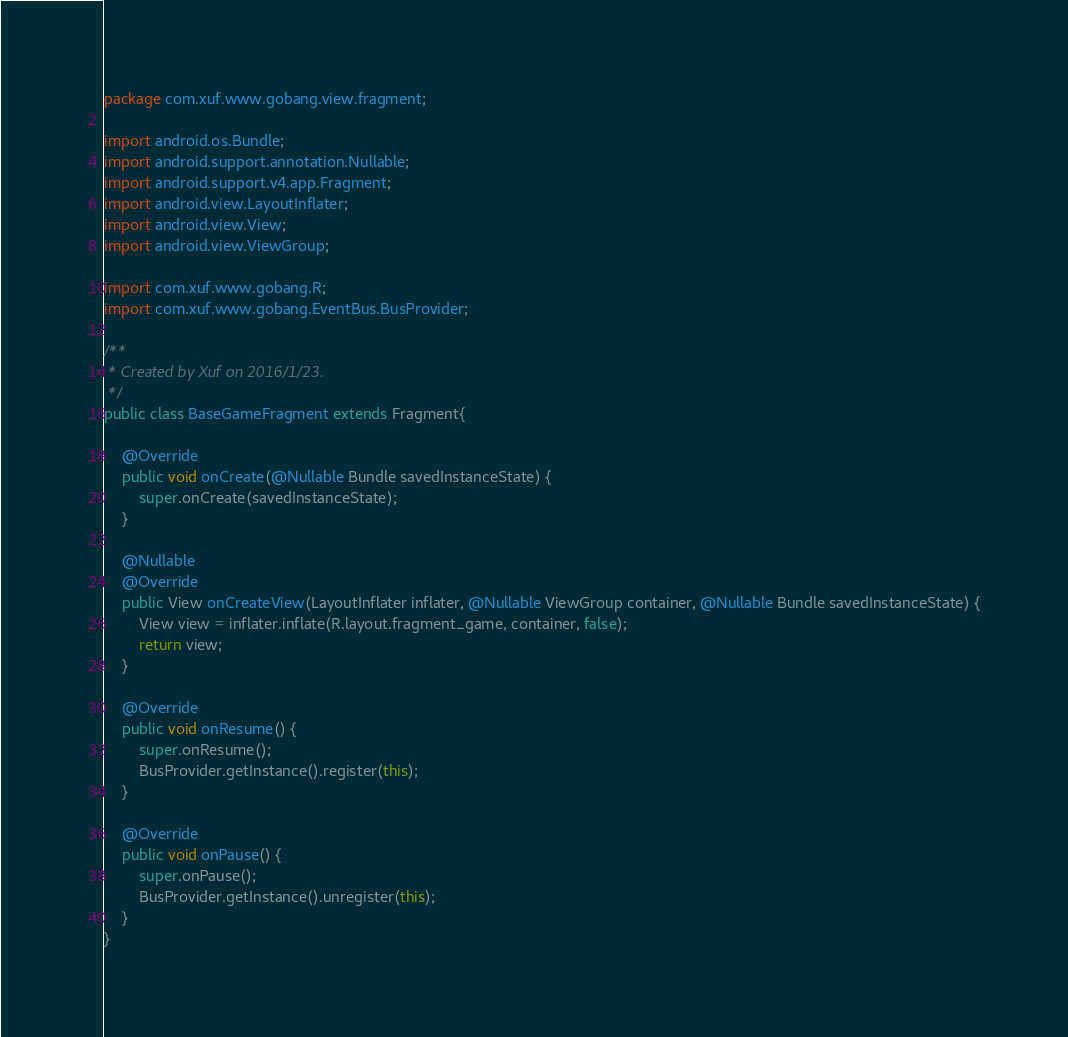<code> <loc_0><loc_0><loc_500><loc_500><_Java_>package com.xuf.www.gobang.view.fragment;

import android.os.Bundle;
import android.support.annotation.Nullable;
import android.support.v4.app.Fragment;
import android.view.LayoutInflater;
import android.view.View;
import android.view.ViewGroup;

import com.xuf.www.gobang.R;
import com.xuf.www.gobang.EventBus.BusProvider;

/**
 * Created by Xuf on 2016/1/23.
 */
public class BaseGameFragment extends Fragment{

    @Override
    public void onCreate(@Nullable Bundle savedInstanceState) {
        super.onCreate(savedInstanceState);
    }

    @Nullable
    @Override
    public View onCreateView(LayoutInflater inflater, @Nullable ViewGroup container, @Nullable Bundle savedInstanceState) {
        View view = inflater.inflate(R.layout.fragment_game, container, false);
        return view;
    }

    @Override
    public void onResume() {
        super.onResume();
        BusProvider.getInstance().register(this);
    }

    @Override
    public void onPause() {
        super.onPause();
        BusProvider.getInstance().unregister(this);
    }
}
</code> 